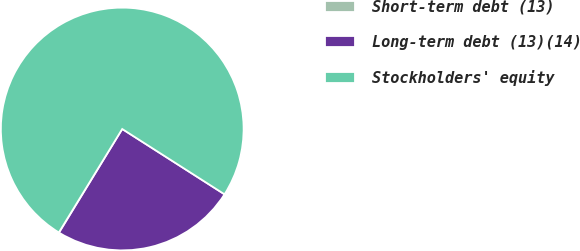<chart> <loc_0><loc_0><loc_500><loc_500><pie_chart><fcel>Short-term debt (13)<fcel>Long-term debt (13)(14)<fcel>Stockholders' equity<nl><fcel>0.03%<fcel>24.67%<fcel>75.3%<nl></chart> 